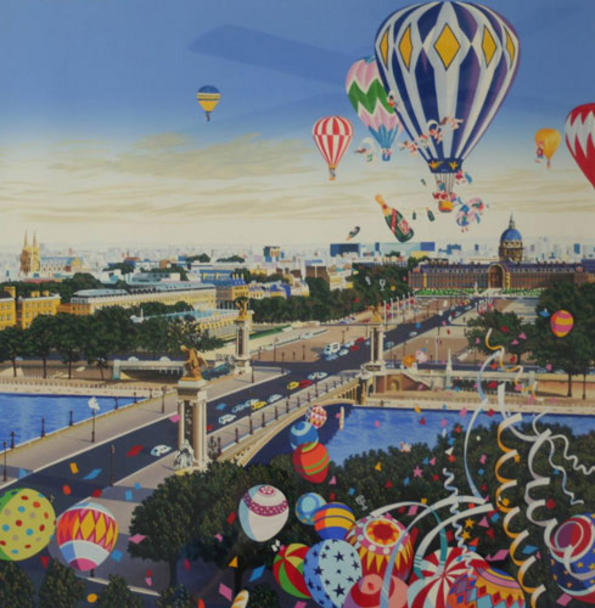What might be the history of this whimsical city? The whimsical city depicted in the image could have a rich history steeped in both reality and fantasy. Perhaps this city was founded centuries ago by a group of visionary architects and artists who envisioned a place where creativity and imagination could flourish. Over time, this city became a hub for inventors, storytellers, and dreamers, each contributing their unique influences to the evolving architectural landscape.

Legend has it that the first hot air balloons were launched by a group of ingenious aeronauts who wanted to explore the skies and share a bird's-eye view of their fantastical creations with the world. These balloonists were revered as pioneers and adventurers, symbolizing the city's spirit of innovation and wonder. Traditions of celebration and festivities centered around these hot air balloons became integral to the city's culture, and they continue to be a defining feature, captivating locals and visitors alike. 